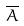Convert formula to latex. <formula><loc_0><loc_0><loc_500><loc_500>\overline { A }</formula> 